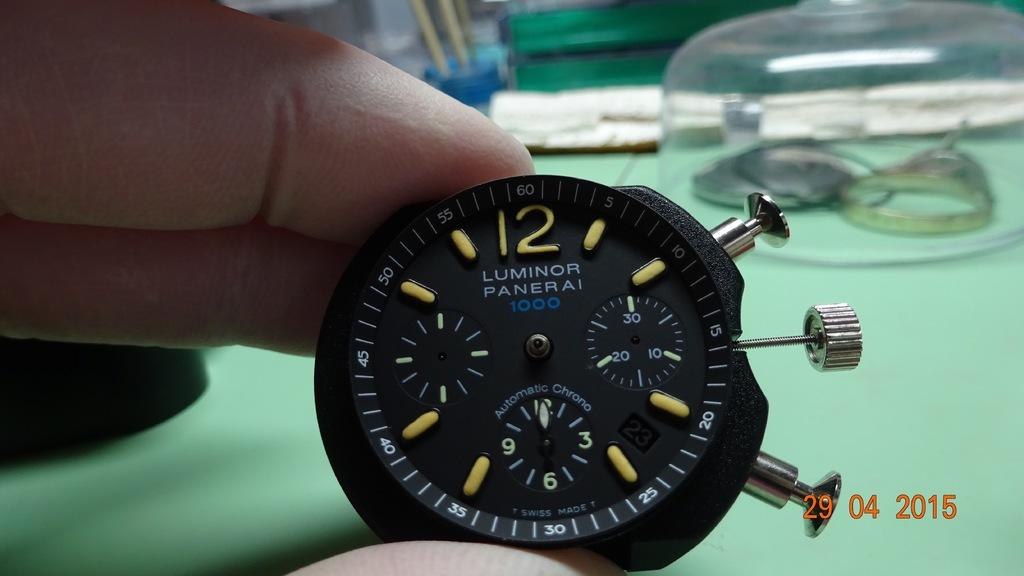<image>
Offer a succinct explanation of the picture presented. a watch with the number 12 at the top of it 